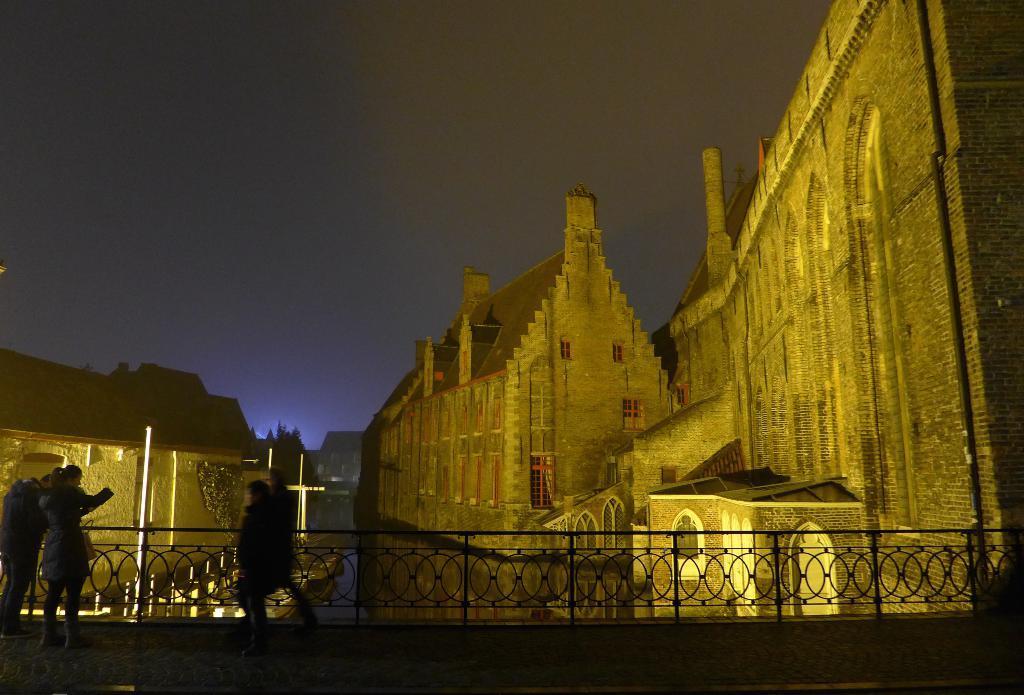Could you give a brief overview of what you see in this image? In this picture there is a brown brick building with roof tiles. In the front there is a metal grill. On the top we can see the sky. 